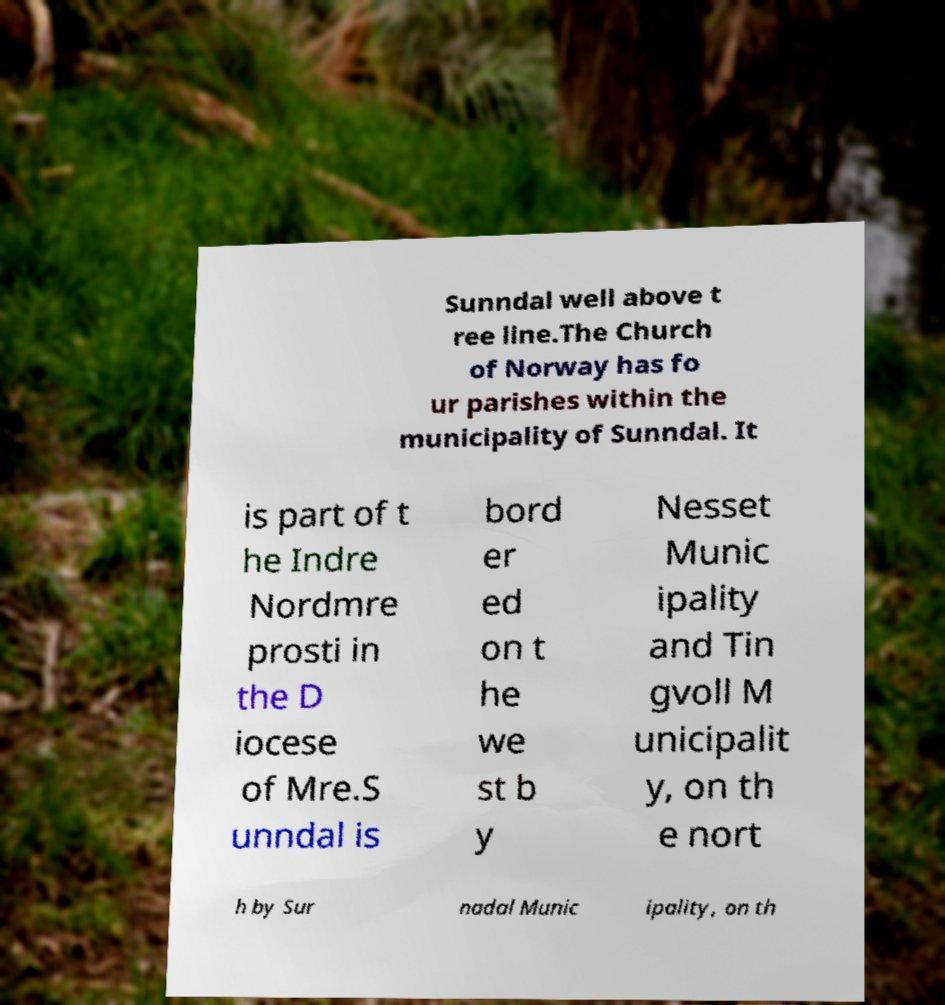What messages or text are displayed in this image? I need them in a readable, typed format. Sunndal well above t ree line.The Church of Norway has fo ur parishes within the municipality of Sunndal. It is part of t he Indre Nordmre prosti in the D iocese of Mre.S unndal is bord er ed on t he we st b y Nesset Munic ipality and Tin gvoll M unicipalit y, on th e nort h by Sur nadal Munic ipality, on th 